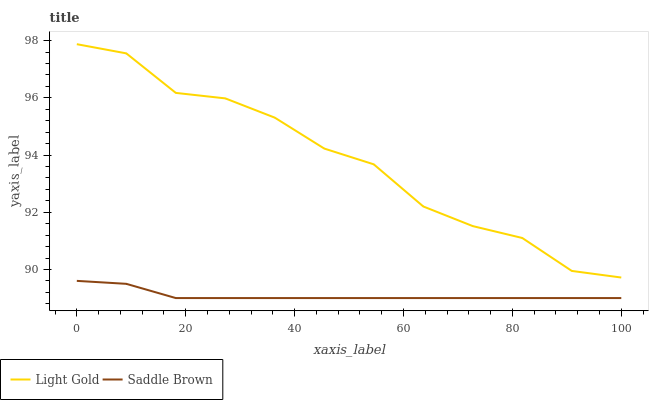Does Saddle Brown have the maximum area under the curve?
Answer yes or no. No. Is Saddle Brown the roughest?
Answer yes or no. No. Does Saddle Brown have the highest value?
Answer yes or no. No. Is Saddle Brown less than Light Gold?
Answer yes or no. Yes. Is Light Gold greater than Saddle Brown?
Answer yes or no. Yes. Does Saddle Brown intersect Light Gold?
Answer yes or no. No. 